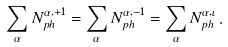<formula> <loc_0><loc_0><loc_500><loc_500>\sum _ { \alpha } N _ { p h } ^ { \alpha , + 1 } = \sum _ { \alpha } N _ { p h } ^ { \alpha , - 1 } = \sum _ { \alpha } N _ { p h } ^ { \alpha , \iota } \, .</formula> 